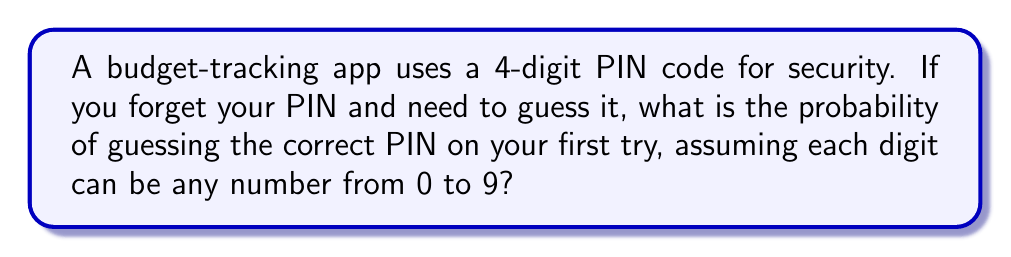Solve this math problem. Let's approach this step-by-step:

1) First, we need to determine the total number of possible 4-digit PIN codes:
   - Each digit can be any number from 0 to 9, so there are 10 possibilities for each digit.
   - We have 4 digits in total.
   - The total number of possible combinations is therefore $10^4 = 10,000$.

2) Now, we need to consider the probability of guessing the correct PIN:
   - There is only one correct PIN out of 10,000 possible combinations.
   - The probability is calculated by dividing the number of favorable outcomes by the total number of possible outcomes.

3) Therefore, the probability of guessing the correct PIN on the first try is:

   $$P(\text{correct guess}) = \frac{\text{number of correct PINs}}{\text{total number of possible PINs}} = \frac{1}{10,000} = 0.0001$$

4) This can also be expressed as a percentage:

   $$0.0001 \times 100\% = 0.01\%$$

This extremely low probability highlights the security of using a 4-digit PIN, making it a cost-effective way for budget-conscious individuals to protect their financial information.
Answer: $\frac{1}{10,000}$ or $0.0001$ or $0.01\%$ 